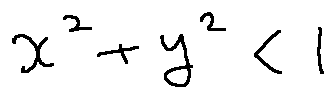Convert formula to latex. <formula><loc_0><loc_0><loc_500><loc_500>x ^ { 2 } + y ^ { 2 } < 1</formula> 